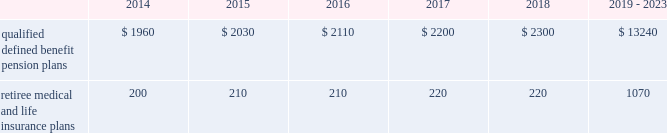Valuation techniques 2013 cash equivalents are mostly comprised of short-term money-market instruments and are valued at cost , which approximates fair value .
U.s .
Equity securities and international equity securities categorized as level 1 are traded on active national and international exchanges and are valued at their closing prices on the last trading day of the year .
For u.s .
Equity securities and international equity securities not traded on an active exchange , or if the closing price is not available , the trustee obtains indicative quotes from a pricing vendor , broker , or investment manager .
These securities are categorized as level 2 if the custodian obtains corroborated quotes from a pricing vendor or categorized as level 3 if the custodian obtains uncorroborated quotes from a broker or investment manager .
Commingled equity funds are investment vehicles valued using the net asset value ( nav ) provided by the fund managers .
The nav is the total value of the fund divided by the number of shares outstanding .
Commingled equity funds are categorized as level 1 if traded at their nav on a nationally recognized securities exchange or categorized as level 2 if the nav is corroborated by observable market data ( e.g. , purchases or sales activity ) and we are able to redeem our investment in the near-term .
Fixed income investments categorized as level 2 are valued by the trustee using pricing models that use verifiable observable market data ( e.g. , interest rates and yield curves observable at commonly quoted intervals and credit spreads ) , bids provided by brokers or dealers , or quoted prices of securities with similar characteristics .
Fixed income investments are categorized at level 3 when valuations using observable inputs are unavailable .
The trustee obtains pricing based on indicative quotes or bid evaluations from vendors , brokers , or the investment manager .
Private equity funds , real estate funds , and hedge funds are valued using the nav based on valuation models of underlying securities which generally include significant unobservable inputs that cannot be corroborated using verifiable observable market data .
Valuations for private equity funds and real estate funds are determined by the general partners .
Depending on the nature of the assets , the general partners may use various valuation methodologies , including the income and market approaches in their models .
The market approach consists of analyzing market transactions for comparable assets while the income approach uses earnings or the net present value of estimated future cash flows adjusted for liquidity and other risk factors .
Hedge funds are valued by independent administrators using various pricing sources and models based on the nature of the securities .
Private equity funds , real estate funds , and hedge funds are generally categorized as level 3 as we cannot fully redeem our investment in the near-term .
Commodities are traded on an active commodity exchange and are valued at their closing prices on the last trading day of the year .
Contributions and expected benefit payments we generally determine funding requirements for our defined benefit pension plans in a manner consistent with cas and internal revenue code rules .
In 2013 , we made contributions of $ 2.25 billion related to our qualified defined benefit pension plans .
We currently plan to make contributions of approximately $ 1.0 billion related to the qualified defined benefit pension plans in 2014 .
In 2013 , we made contributions of $ 98 million to our retiree medical and life insurance plans .
We do not expect to make contributions related to the retiree medical and life insurance plans in 2014 as a result of our 2013 contributions .
The table presents estimated future benefit payments , which reflect expected future employee service , as of december 31 , 2013 ( in millions ) : .
Defined contribution plans we maintain a number of defined contribution plans , most with 401 ( k ) features , that cover substantially all of our employees .
Under the provisions of our 401 ( k ) plans , we match most employees 2019 eligible contributions at rates specified in the plan documents .
Our contributions were $ 383 million in 2013 , $ 380 million in 2012 , and $ 378 million in 2011 , the majority of which were funded in our common stock .
Our defined contribution plans held approximately 44.7 million and 48.6 million shares of our common stock as of december 31 , 2013 and 2012. .
What was the ratio of the company contribution to the pension plan in 2013 to 2014? 
Computations: (2.25 / 1.0)
Answer: 2.25. 